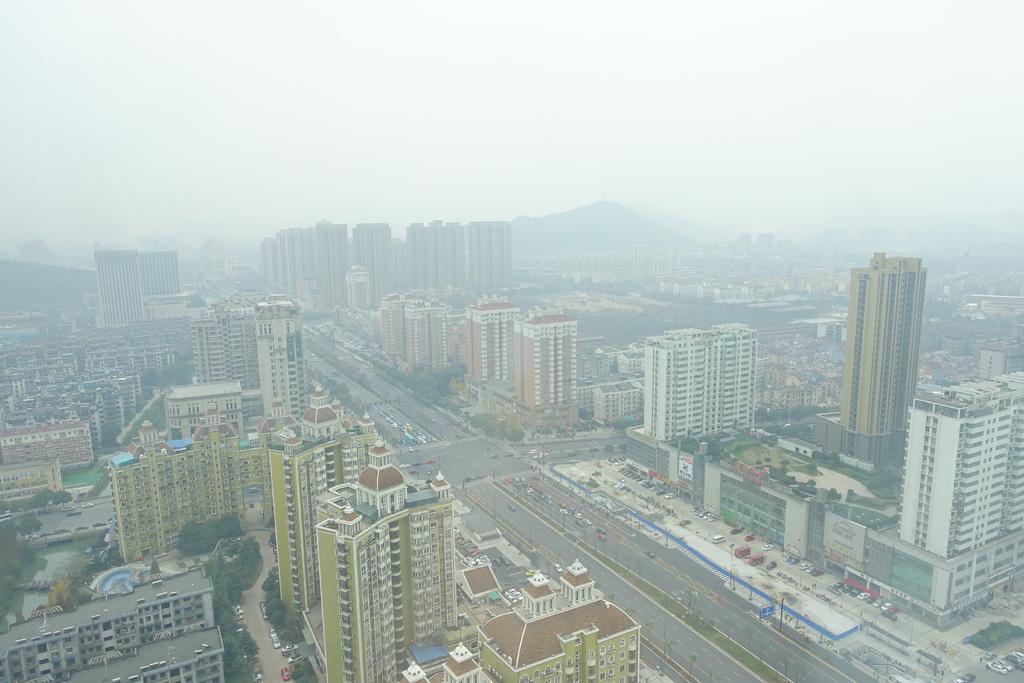Describe this image in one or two sentences. This is an aerial view image of a place which consists of buildings, trees, roads, vehicles and mountains. 